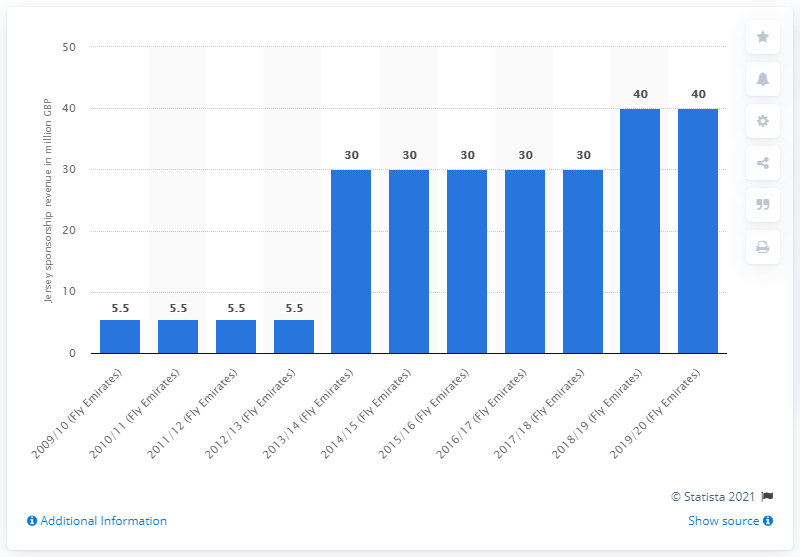List a handful of essential elements in this visual. Arsenal received 40 million GBP from Fly Emirates in the 2019/20 season. 